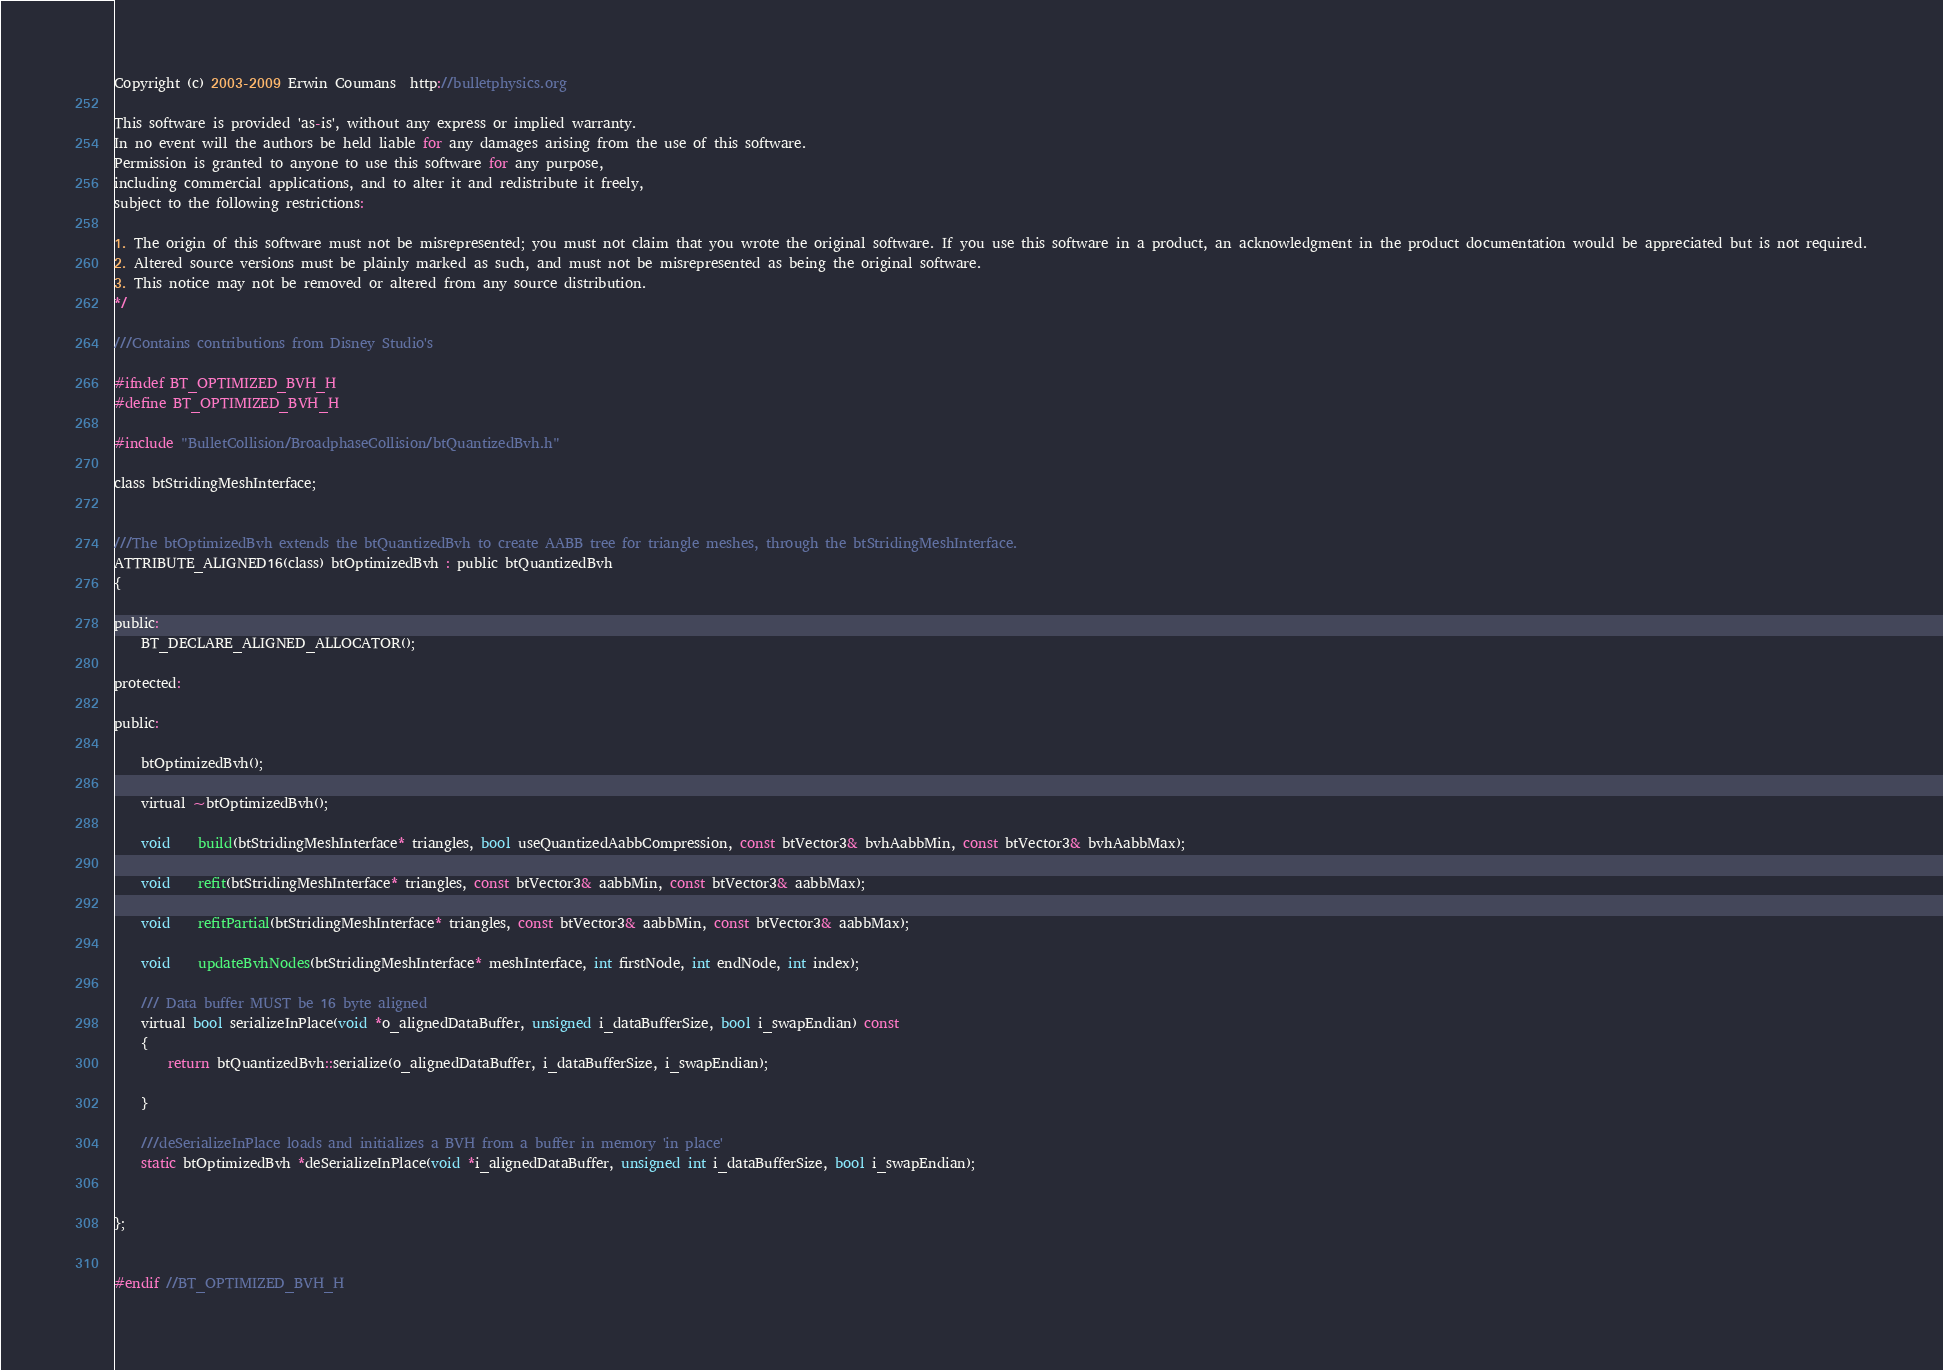<code> <loc_0><loc_0><loc_500><loc_500><_C_>Copyright (c) 2003-2009 Erwin Coumans  http://bulletphysics.org

This software is provided 'as-is', without any express or implied warranty.
In no event will the authors be held liable for any damages arising from the use of this software.
Permission is granted to anyone to use this software for any purpose, 
including commercial applications, and to alter it and redistribute it freely, 
subject to the following restrictions:

1. The origin of this software must not be misrepresented; you must not claim that you wrote the original software. If you use this software in a product, an acknowledgment in the product documentation would be appreciated but is not required.
2. Altered source versions must be plainly marked as such, and must not be misrepresented as being the original software.
3. This notice may not be removed or altered from any source distribution.
*/

///Contains contributions from Disney Studio's

#ifndef BT_OPTIMIZED_BVH_H
#define BT_OPTIMIZED_BVH_H

#include "BulletCollision/BroadphaseCollision/btQuantizedBvh.h"

class btStridingMeshInterface;


///The btOptimizedBvh extends the btQuantizedBvh to create AABB tree for triangle meshes, through the btStridingMeshInterface.
ATTRIBUTE_ALIGNED16(class) btOptimizedBvh : public btQuantizedBvh
{
	
public:
	BT_DECLARE_ALIGNED_ALLOCATOR();

protected:

public:

	btOptimizedBvh();

	virtual ~btOptimizedBvh();

	void	build(btStridingMeshInterface* triangles, bool useQuantizedAabbCompression, const btVector3& bvhAabbMin, const btVector3& bvhAabbMax);

	void	refit(btStridingMeshInterface* triangles, const btVector3& aabbMin, const btVector3& aabbMax);

	void	refitPartial(btStridingMeshInterface* triangles, const btVector3& aabbMin, const btVector3& aabbMax);

	void	updateBvhNodes(btStridingMeshInterface* meshInterface, int firstNode, int endNode, int index);

	/// Data buffer MUST be 16 byte aligned
	virtual bool serializeInPlace(void *o_alignedDataBuffer, unsigned i_dataBufferSize, bool i_swapEndian) const
	{
		return btQuantizedBvh::serialize(o_alignedDataBuffer, i_dataBufferSize, i_swapEndian);

	}

	///deSerializeInPlace loads and initializes a BVH from a buffer in memory 'in place'
	static btOptimizedBvh *deSerializeInPlace(void *i_alignedDataBuffer, unsigned int i_dataBufferSize, bool i_swapEndian);


};


#endif //BT_OPTIMIZED_BVH_H


</code> 